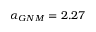Convert formula to latex. <formula><loc_0><loc_0><loc_500><loc_500>\alpha _ { G N M } = 2 . 2 7</formula> 